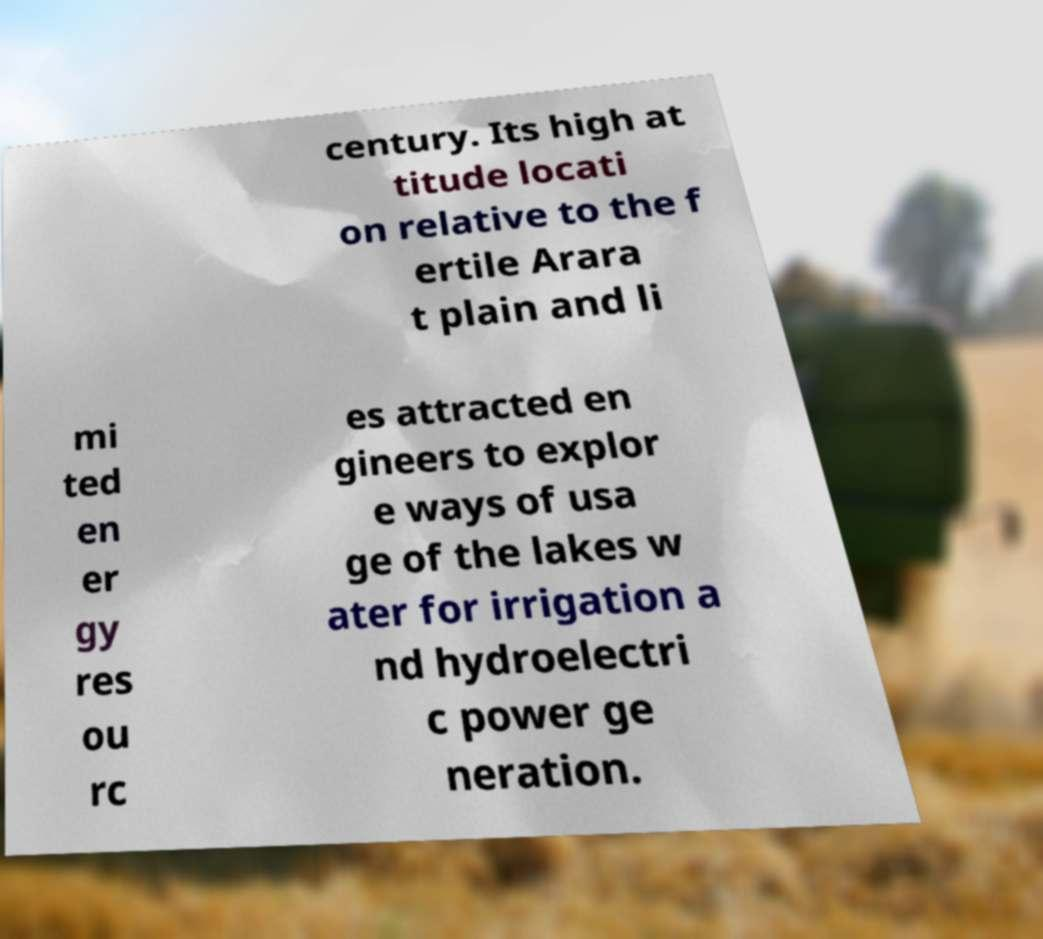Could you extract and type out the text from this image? century. Its high at titude locati on relative to the f ertile Arara t plain and li mi ted en er gy res ou rc es attracted en gineers to explor e ways of usa ge of the lakes w ater for irrigation a nd hydroelectri c power ge neration. 